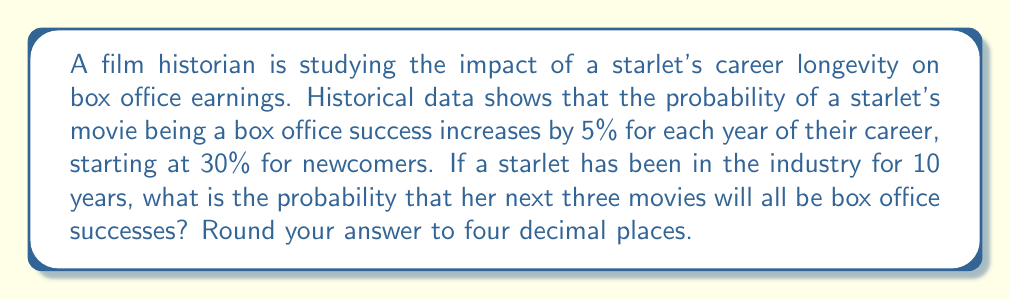Can you solve this math problem? Let's approach this step-by-step:

1) First, we need to calculate the probability of a single movie being a box office success after 10 years in the industry.

   Initial probability: 30% = 0.30
   Increase per year: 5% = 0.05
   Years in industry: 10

   Probability after 10 years = $0.30 + (10 \times 0.05) = 0.80$ or 80%

2) Now, we need to calculate the probability of all three movies being successful. This is a case of independent events, where the probability of each event is the same (0.80).

3) The probability of all independent events occurring is the product of their individual probabilities. In this case:

   $$P(\text{all 3 successful}) = 0.80 \times 0.80 \times 0.80 = 0.80^3$$

4) Let's calculate this:

   $$0.80^3 = 0.512$$

5) Rounding to four decimal places:

   0.5120
Answer: 0.5120 